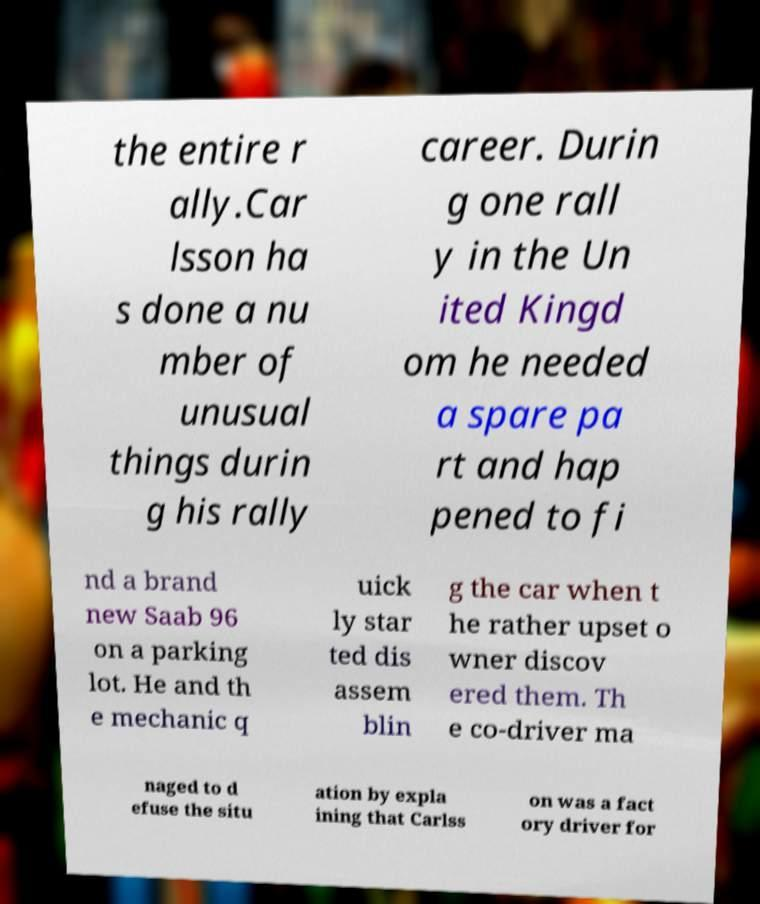Please read and relay the text visible in this image. What does it say? the entire r ally.Car lsson ha s done a nu mber of unusual things durin g his rally career. Durin g one rall y in the Un ited Kingd om he needed a spare pa rt and hap pened to fi nd a brand new Saab 96 on a parking lot. He and th e mechanic q uick ly star ted dis assem blin g the car when t he rather upset o wner discov ered them. Th e co-driver ma naged to d efuse the situ ation by expla ining that Carlss on was a fact ory driver for 